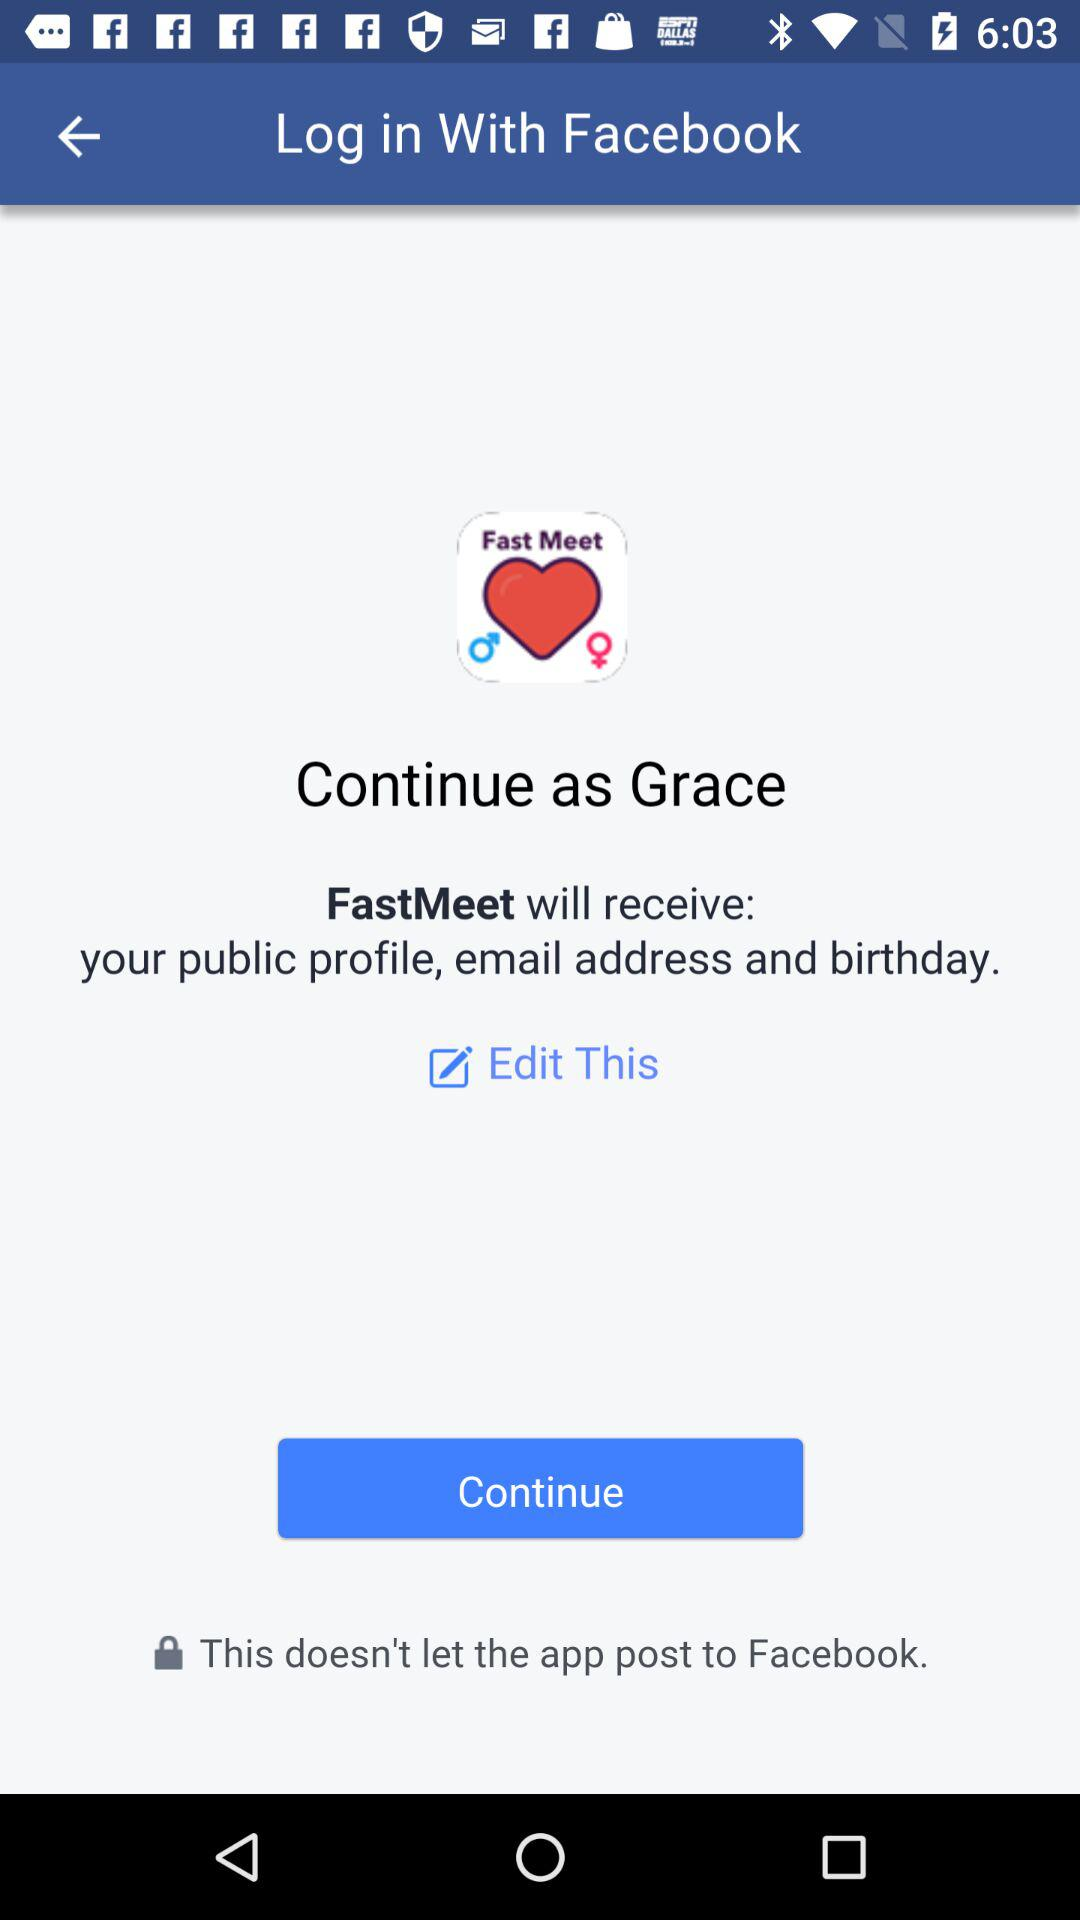What's the name of the application that will receive the public profile and email address? The name of the application is "FastMeet". 